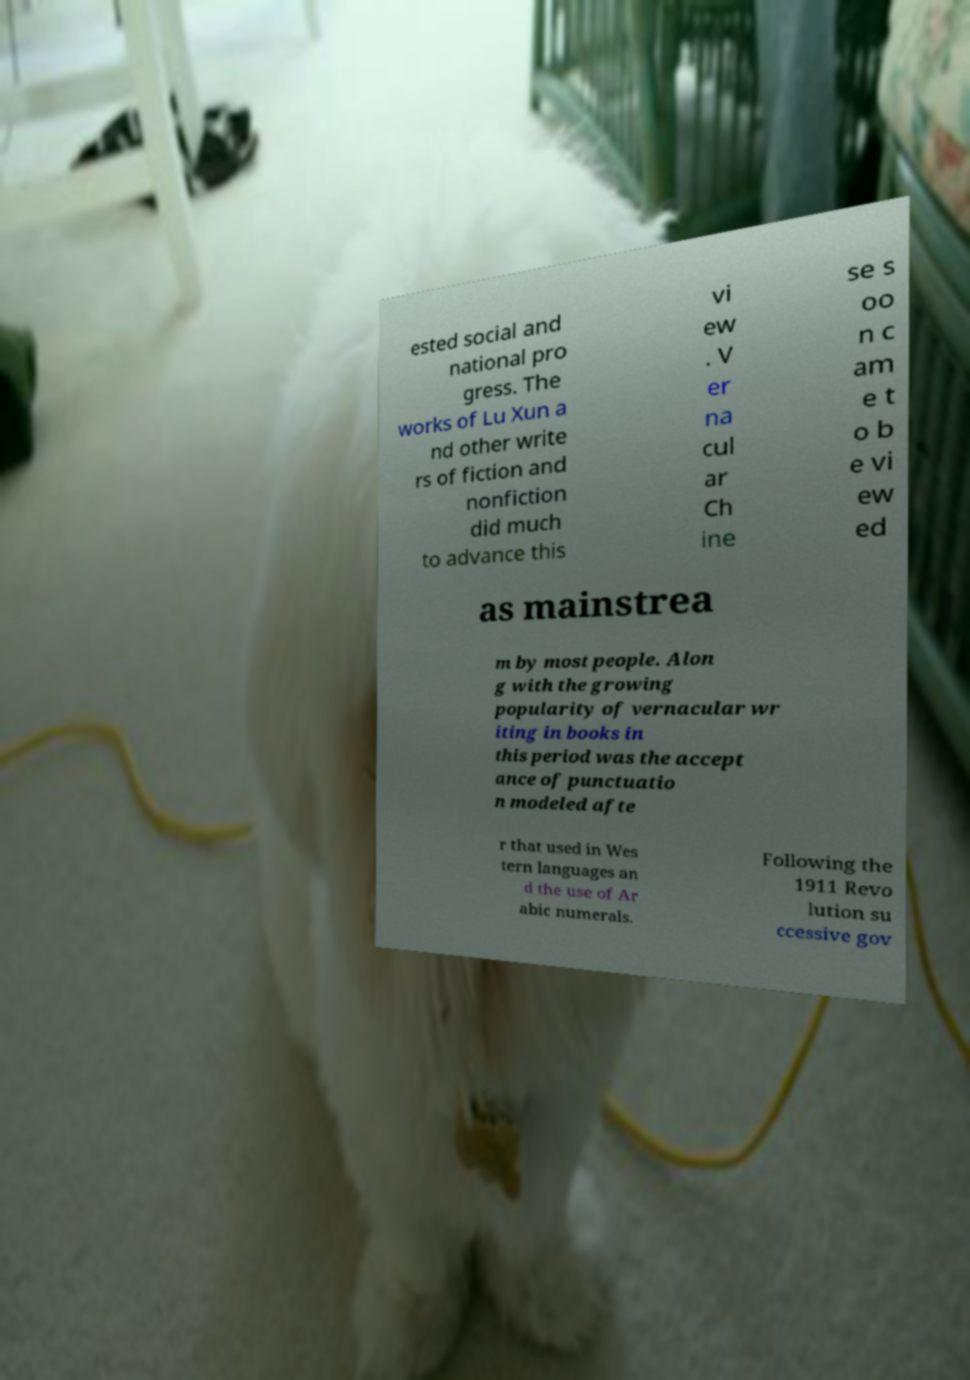What messages or text are displayed in this image? I need them in a readable, typed format. ested social and national pro gress. The works of Lu Xun a nd other write rs of fiction and nonfiction did much to advance this vi ew . V er na cul ar Ch ine se s oo n c am e t o b e vi ew ed as mainstrea m by most people. Alon g with the growing popularity of vernacular wr iting in books in this period was the accept ance of punctuatio n modeled afte r that used in Wes tern languages an d the use of Ar abic numerals. Following the 1911 Revo lution su ccessive gov 